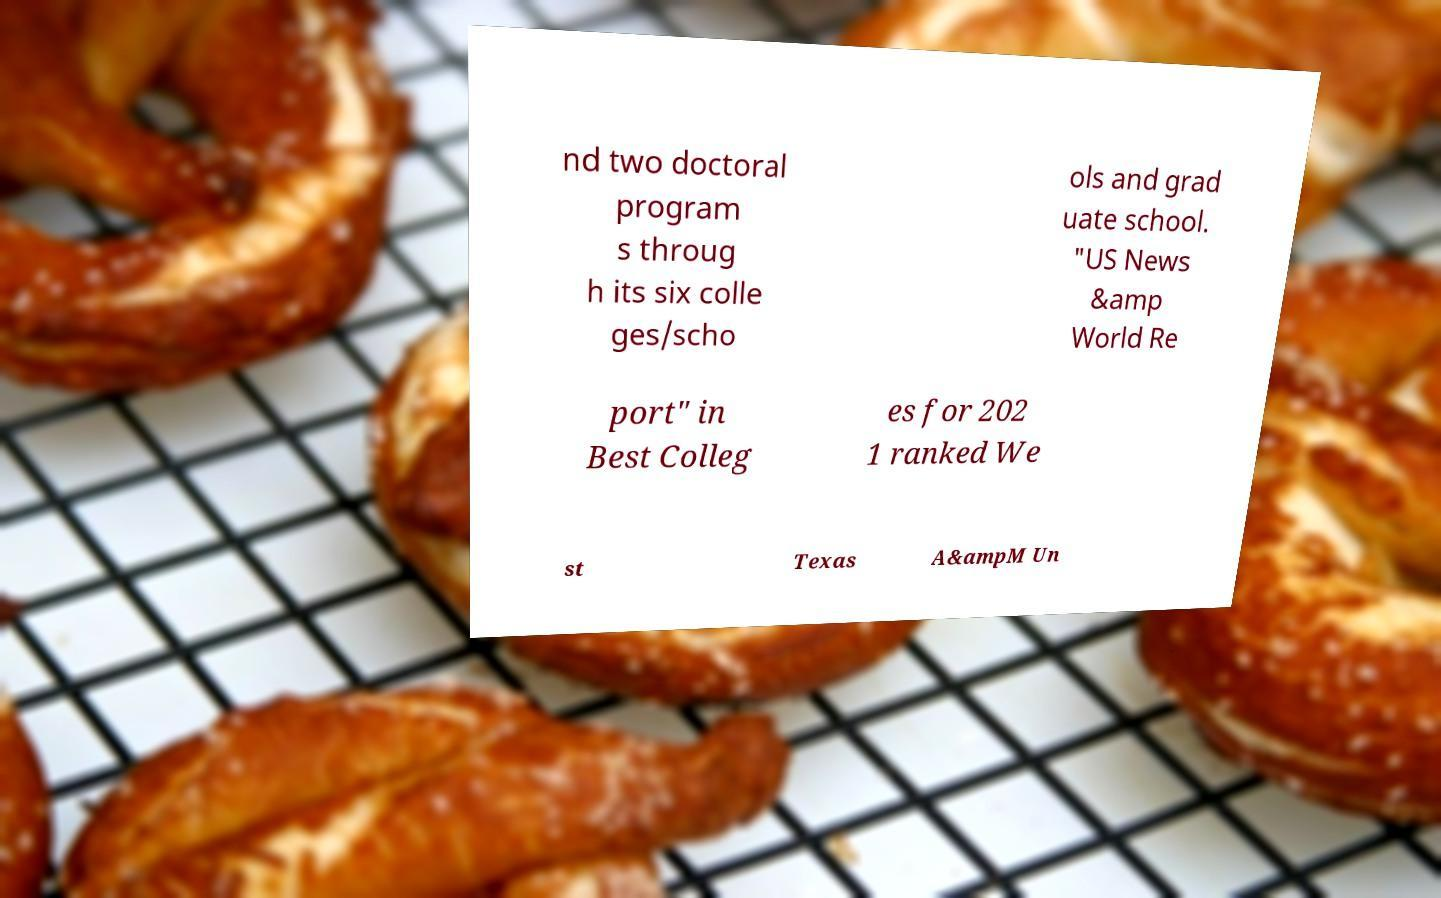For documentation purposes, I need the text within this image transcribed. Could you provide that? nd two doctoral program s throug h its six colle ges/scho ols and grad uate school. "US News &amp World Re port" in Best Colleg es for 202 1 ranked We st Texas A&ampM Un 